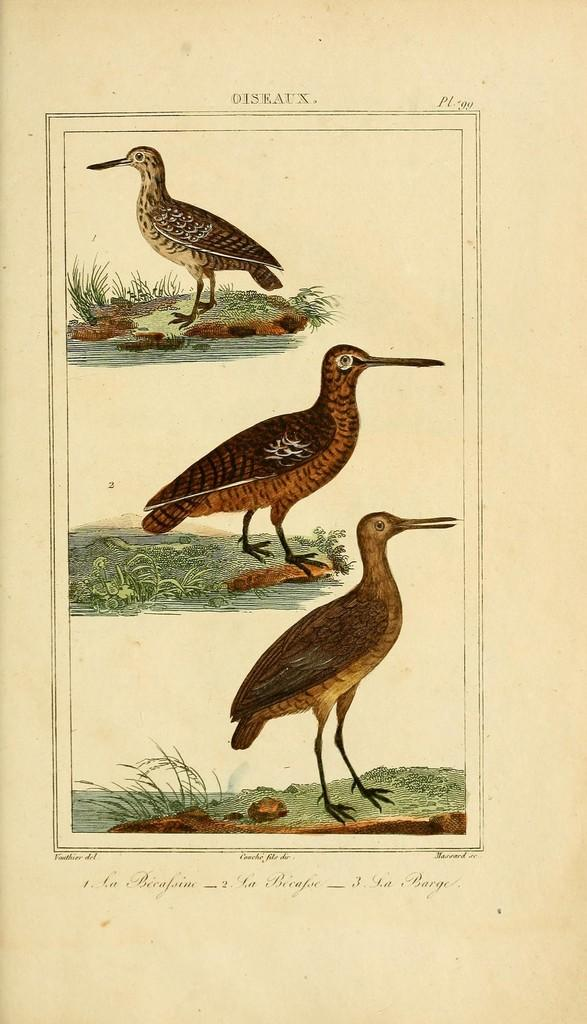What is featured on the poster in the image? The poster contains three birds, plants, grass, and water. Can you describe the setting depicted on the poster? The poster depicts a scene with birds, plants, grass, and water, which suggests a natural environment. What type of hen can be seen interacting with the coach in the image? There is no hen or coach present in the image; the poster only contains birds, plants, grass, and water. 